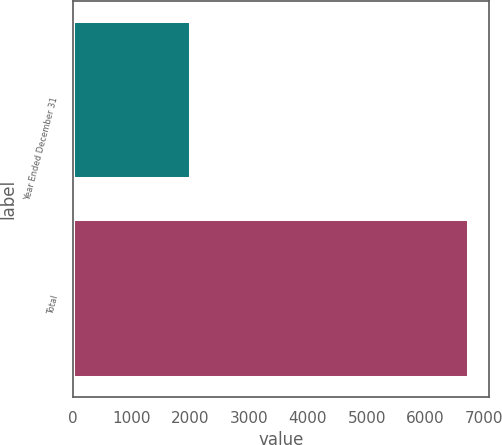Convert chart. <chart><loc_0><loc_0><loc_500><loc_500><bar_chart><fcel>Year Ended December 31<fcel>Total<nl><fcel>2017<fcel>6742<nl></chart> 